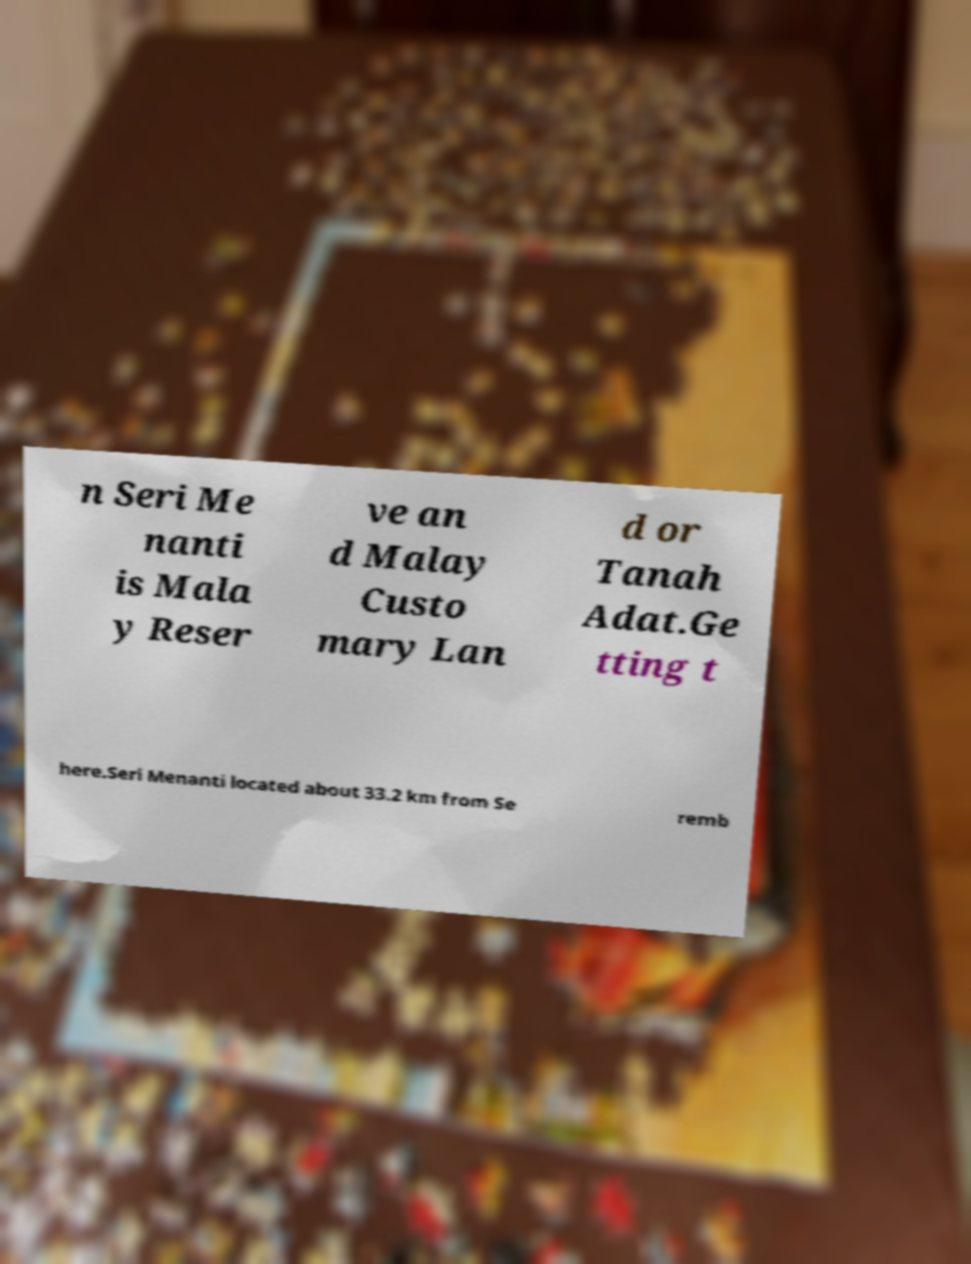For documentation purposes, I need the text within this image transcribed. Could you provide that? n Seri Me nanti is Mala y Reser ve an d Malay Custo mary Lan d or Tanah Adat.Ge tting t here.Seri Menanti located about 33.2 km from Se remb 